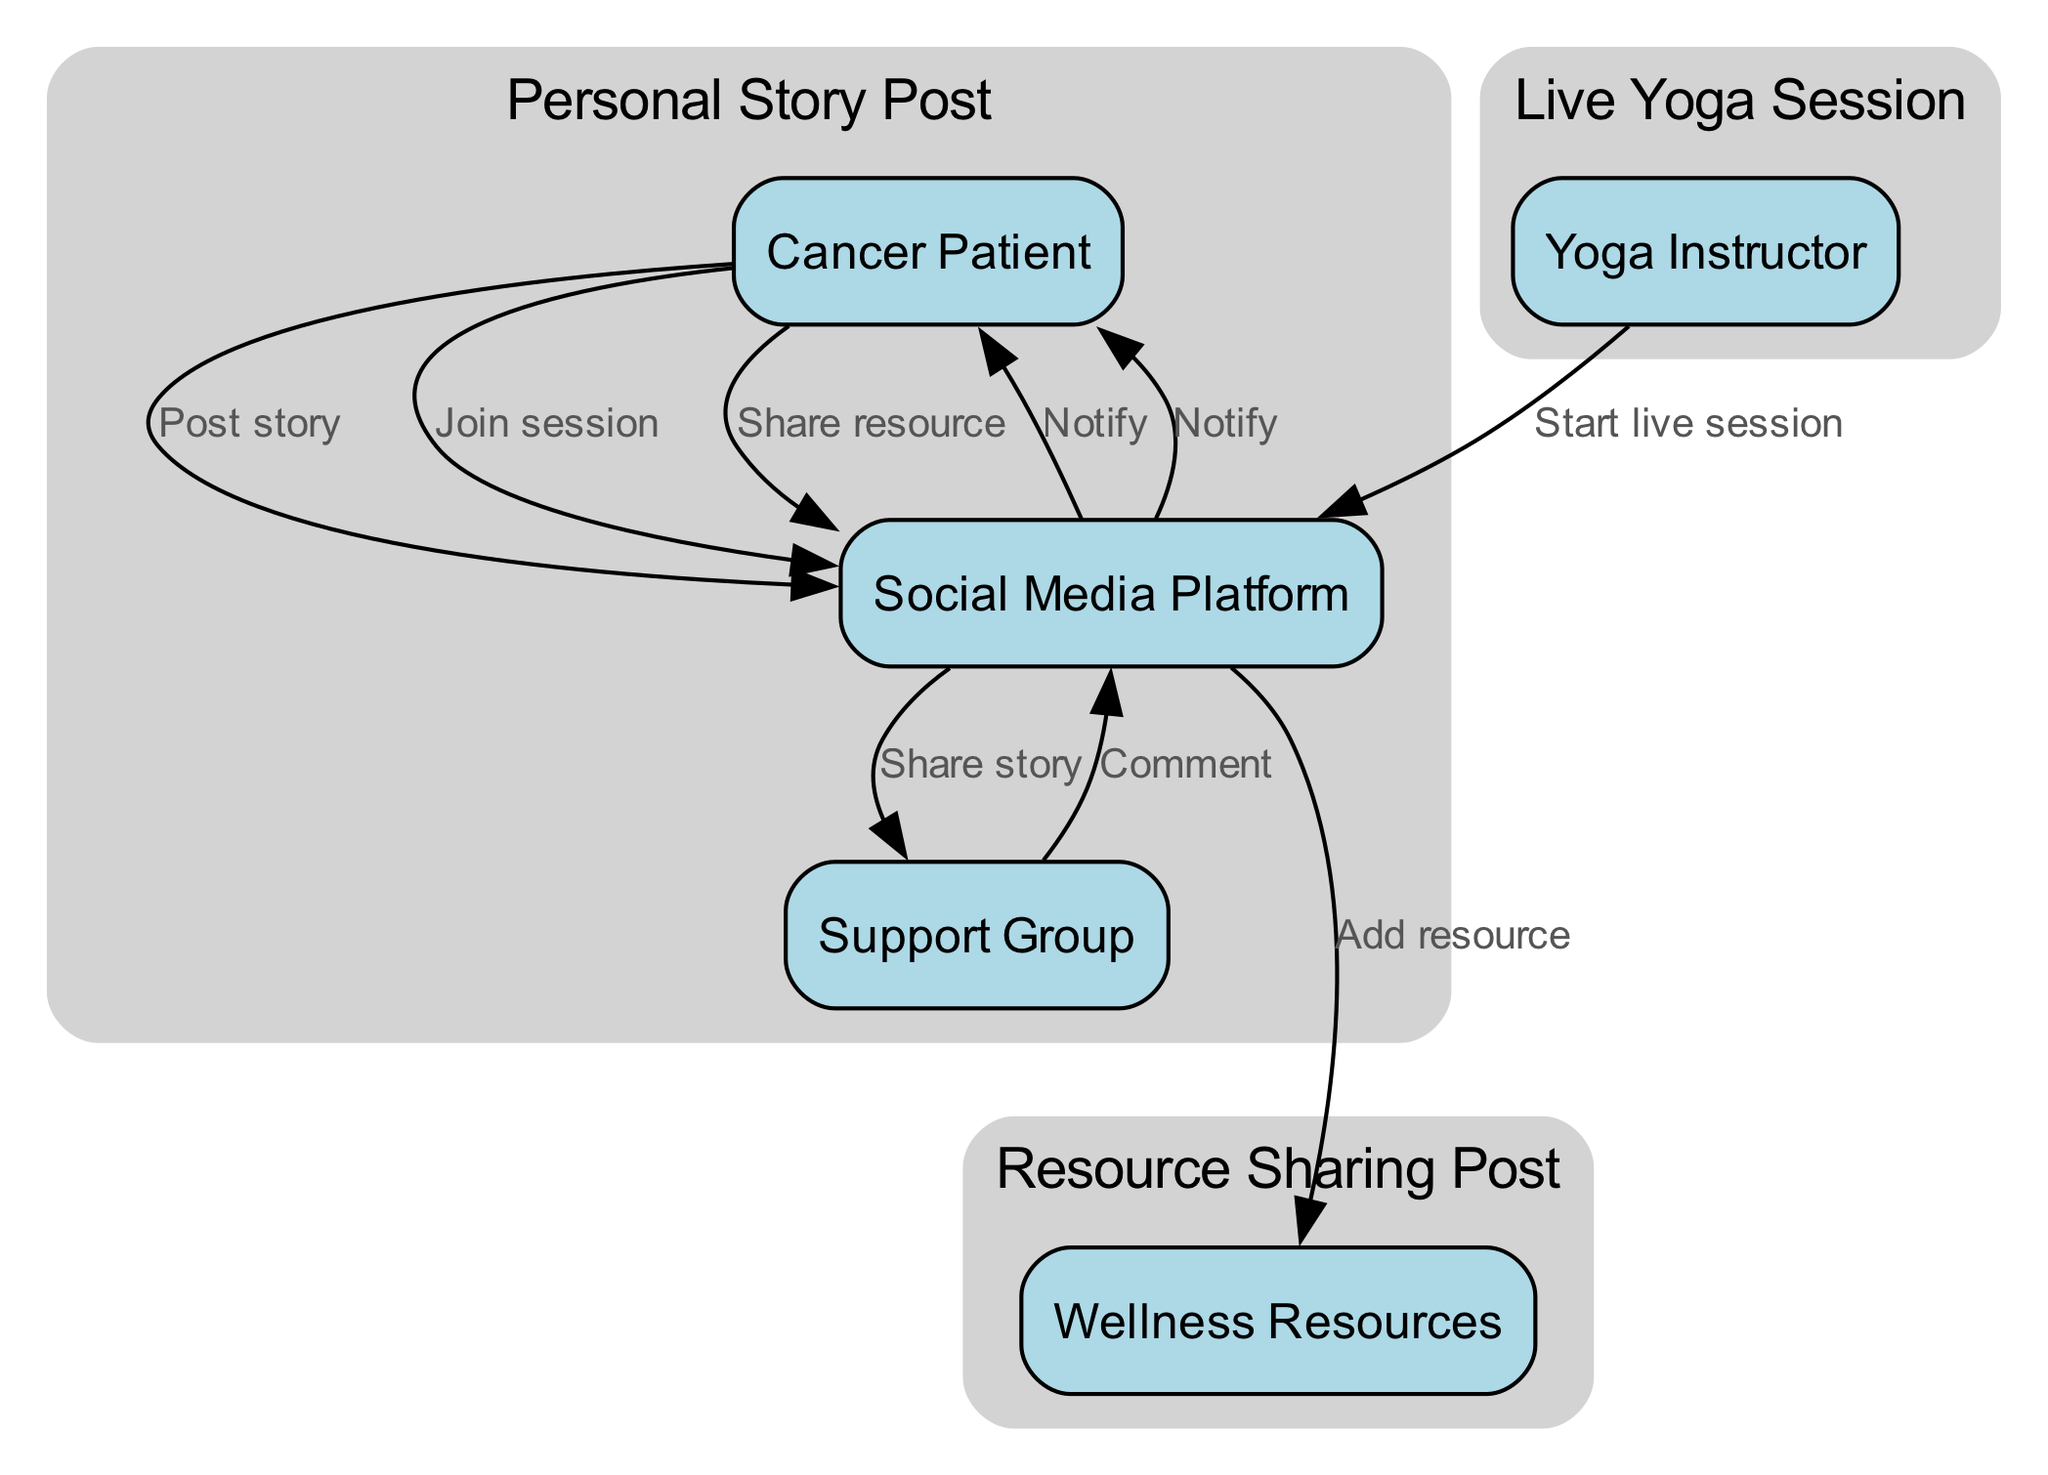What are the three main actors in the diagram? The three main actors are the Cancer Patient, Yoga Instructor, and Social Media Platform. These actors are visually represented in the diagram, thus making them identifiable.
Answer: Cancer Patient, Yoga Instructor, Social Media Platform How many interaction types are present in the diagram? There are four types of interactions defined in the diagram: Personal Story Post, Live Yoga Session, Resource Sharing Post, and Comment and Support. Counting these will yield the number four.
Answer: 4 Which actor initiates the Live Yoga Session? The Yoga Instructor initiates the Live Yoga Session, as indicated by the arrow going from the Yoga Instructor to the Social Media Platform labeled 'Start live session.'
Answer: Yoga Instructor What action does the Cancer Patient take in the Resource Sharing Post? In the Resource Sharing Post, the action taken by the Cancer Patient is to share a resource, as indicated in the edge leading from the Cancer Patient to the Social Media Platform labeled 'Share resource.'
Answer: Share resource How does the Support Group interact with the Cancer Patient in the diagram? The Support Group interacts with the Cancer Patient through commenting and support. The diagram shows an edge from the Support Group to the Social Media Platform for commenting, which subsequently alerts the Cancer Patient.
Answer: Comment and support What is the relationship between the Social Media Platform and Wellness Resources? The relationship is that the Social Media Platform adds resources to the Wellness Resources entity when a resource is shared, as shown by the directed edge from the Social Media Platform to the Wellness Resources.
Answer: Add resource How many total connections (edges) are there in the interactions section of the diagram? By analyzing the connections in the interaction section, we observe a total of six edges: one for each action step defined, leading to the conclusion there are six connections.
Answer: 6 Which interaction follows the Personal Story Post? The interaction that follows the Personal Story Post in the sequence is the Live Yoga Session. This can be inferred from the ordered nature of the interactions listed in the diagram.
Answer: Live Yoga Session 